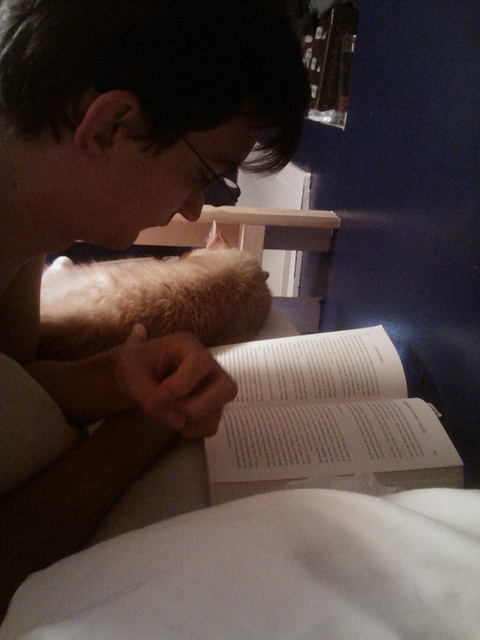Describe the objects in this image and their specific colors. I can see people in black, maroon, and gray tones, bed in black, darkgray, and gray tones, book in black, gray, maroon, and lightgray tones, and cat in black, maroon, tan, and gray tones in this image. 